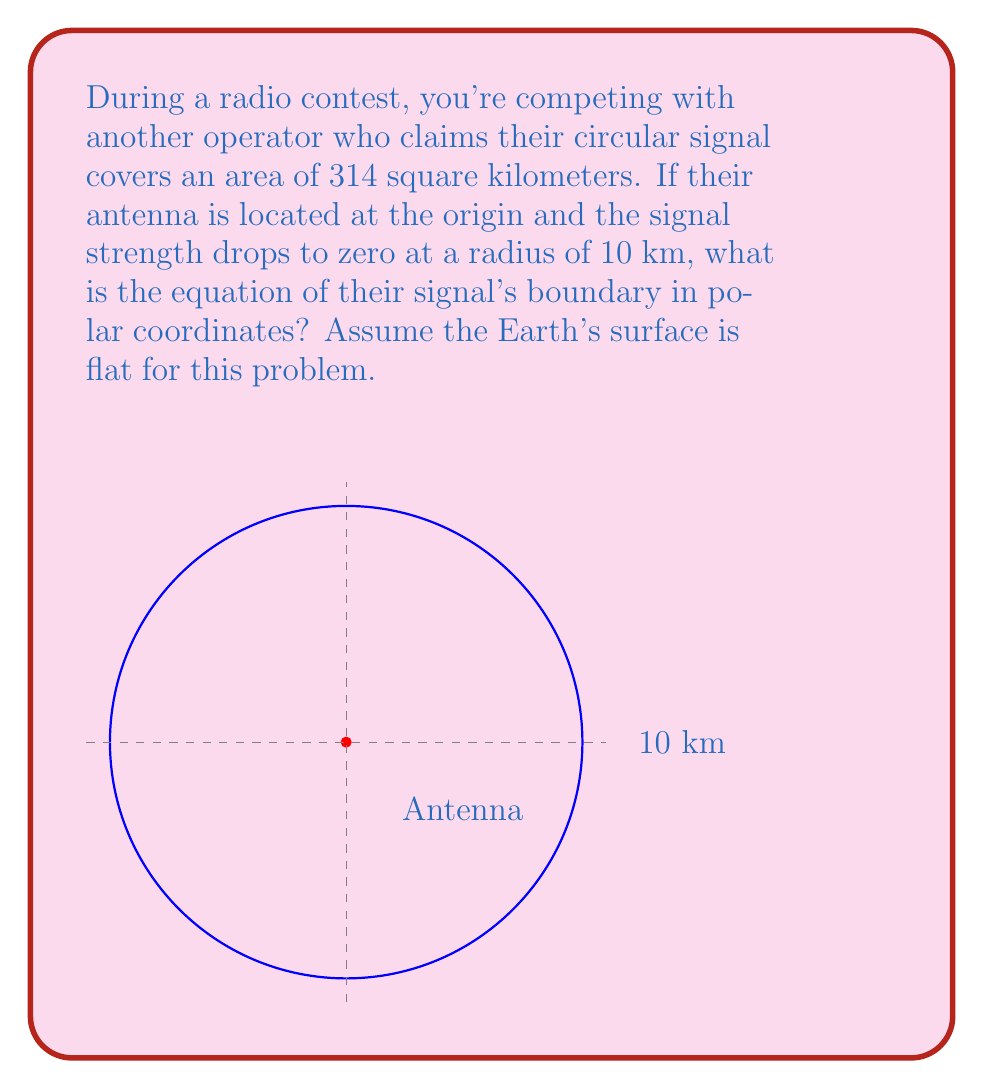Provide a solution to this math problem. Let's approach this step-by-step:

1) In polar coordinates, a circle centered at the origin is represented by the equation $r = a$, where $a$ is the radius of the circle.

2) We're given that the signal strength drops to zero at a radius of 10 km. This means the circle has a radius of 10 km.

3) Therefore, the equation of the circle in polar coordinates is simply:

   $r = 10$

4) To verify this, we can calculate the area of this circle:
   
   Area $= \pi r^2 = \pi (10)^2 = 100\pi \approx 314$ square kilometers

   This matches the given area in the problem statement.

5) In polar form, this equation means that for any angle $\theta$, the distance from the origin (where the antenna is located) to the boundary of the signal is always 10 km.
Answer: $r = 10$ 